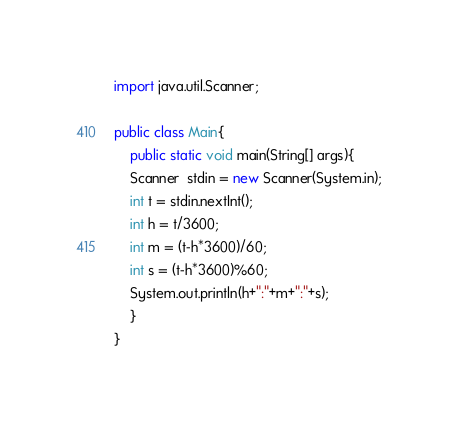<code> <loc_0><loc_0><loc_500><loc_500><_Java_>import java.util.Scanner;

public class Main{
    public static void main(String[] args){
	Scanner  stdin = new Scanner(System.in);
	int t = stdin.nextInt();
	int h = t/3600;
	int m = (t-h*3600)/60;
	int s = (t-h*3600)%60;
	System.out.println(h+":"+m+":"+s);
    }
}</code> 